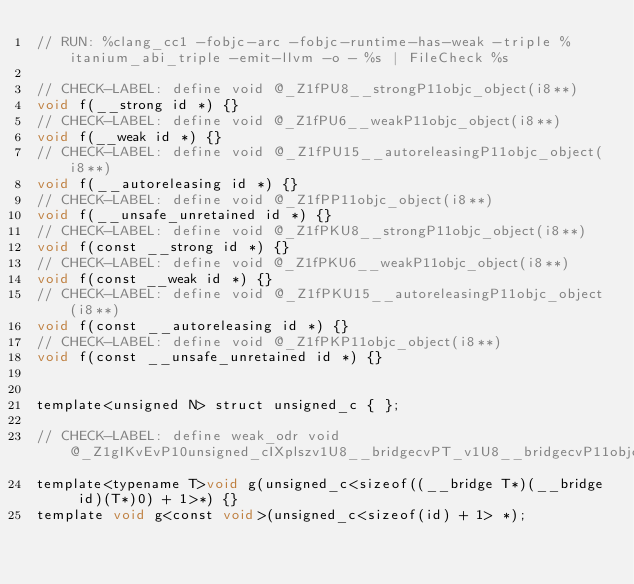Convert code to text. <code><loc_0><loc_0><loc_500><loc_500><_ObjectiveC_>// RUN: %clang_cc1 -fobjc-arc -fobjc-runtime-has-weak -triple %itanium_abi_triple -emit-llvm -o - %s | FileCheck %s

// CHECK-LABEL: define void @_Z1fPU8__strongP11objc_object(i8**)
void f(__strong id *) {}
// CHECK-LABEL: define void @_Z1fPU6__weakP11objc_object(i8**)
void f(__weak id *) {}
// CHECK-LABEL: define void @_Z1fPU15__autoreleasingP11objc_object(i8**)
void f(__autoreleasing id *) {}
// CHECK-LABEL: define void @_Z1fPP11objc_object(i8**)
void f(__unsafe_unretained id *) {}
// CHECK-LABEL: define void @_Z1fPKU8__strongP11objc_object(i8**)
void f(const __strong id *) {}
// CHECK-LABEL: define void @_Z1fPKU6__weakP11objc_object(i8**)
void f(const __weak id *) {}
// CHECK-LABEL: define void @_Z1fPKU15__autoreleasingP11objc_object(i8**)
void f(const __autoreleasing id *) {}
// CHECK-LABEL: define void @_Z1fPKP11objc_object(i8**)
void f(const __unsafe_unretained id *) {}


template<unsigned N> struct unsigned_c { };

// CHECK-LABEL: define weak_odr void @_Z1gIKvEvP10unsigned_cIXplszv1U8__bridgecvPT_v1U8__bridgecvP11objc_objectcvS3_Li0ELi1EEE
template<typename T>void g(unsigned_c<sizeof((__bridge T*)(__bridge id)(T*)0) + 1>*) {}
template void g<const void>(unsigned_c<sizeof(id) + 1> *);
</code> 